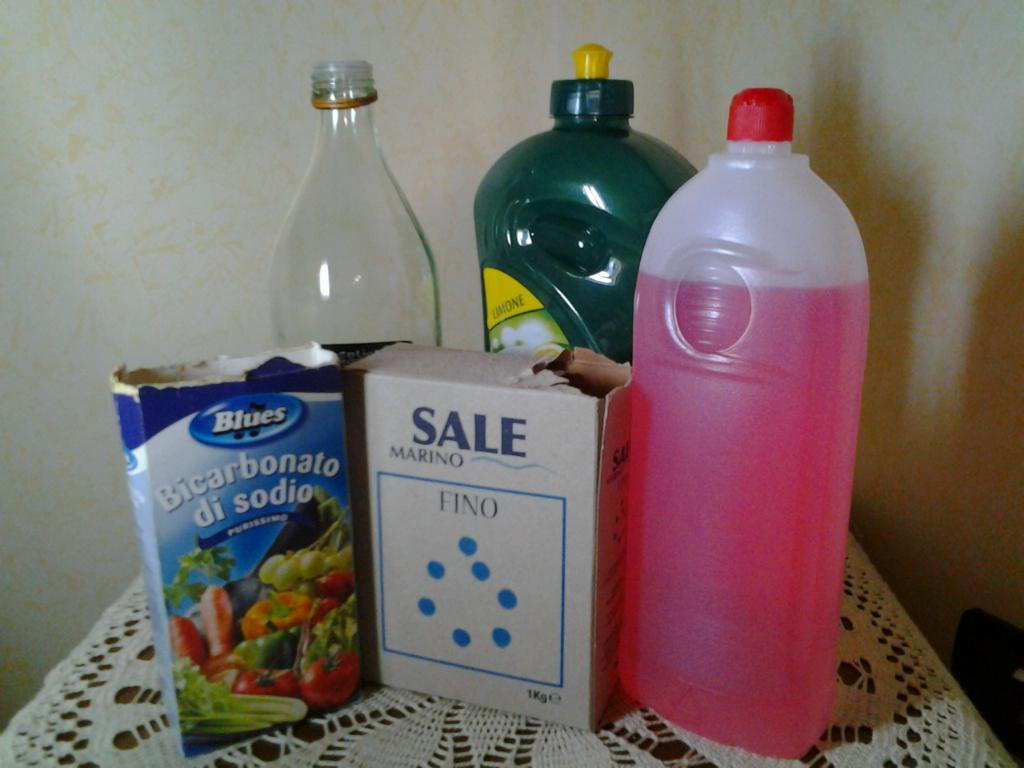<image>
Relay a brief, clear account of the picture shown. a white Sale box next to other grocery items 